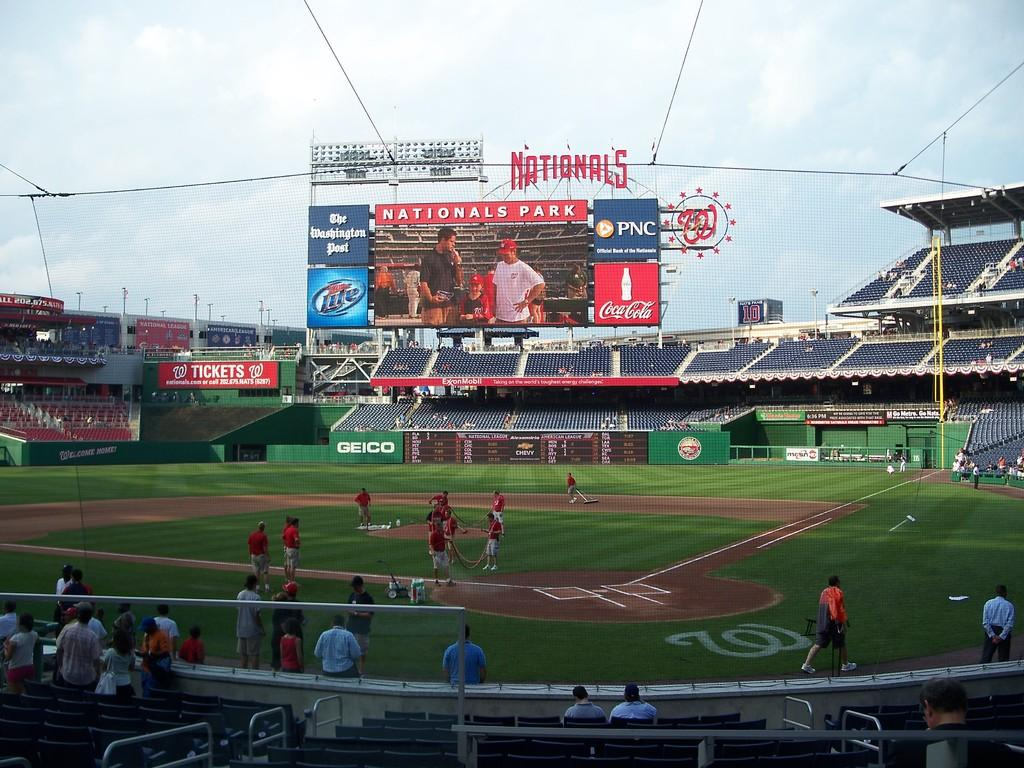<image>
Render a clear and concise summary of the photo. Baseball Stadium with a large screen that has Nationals Parks in white lettering at the top. 